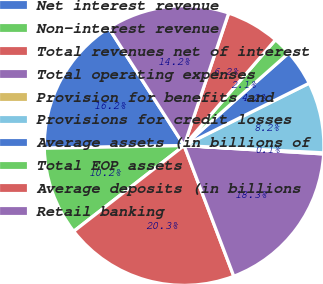Convert chart to OTSL. <chart><loc_0><loc_0><loc_500><loc_500><pie_chart><fcel>Net interest revenue<fcel>Non-interest revenue<fcel>Total revenues net of interest<fcel>Total operating expenses<fcel>Provision for benefits and<fcel>Provisions for credit losses<fcel>Average assets (in billions of<fcel>Total EOP assets<fcel>Average deposits (in billions<fcel>Retail banking<nl><fcel>16.24%<fcel>10.2%<fcel>20.27%<fcel>18.26%<fcel>0.13%<fcel>8.19%<fcel>4.16%<fcel>2.14%<fcel>6.17%<fcel>14.23%<nl></chart> 